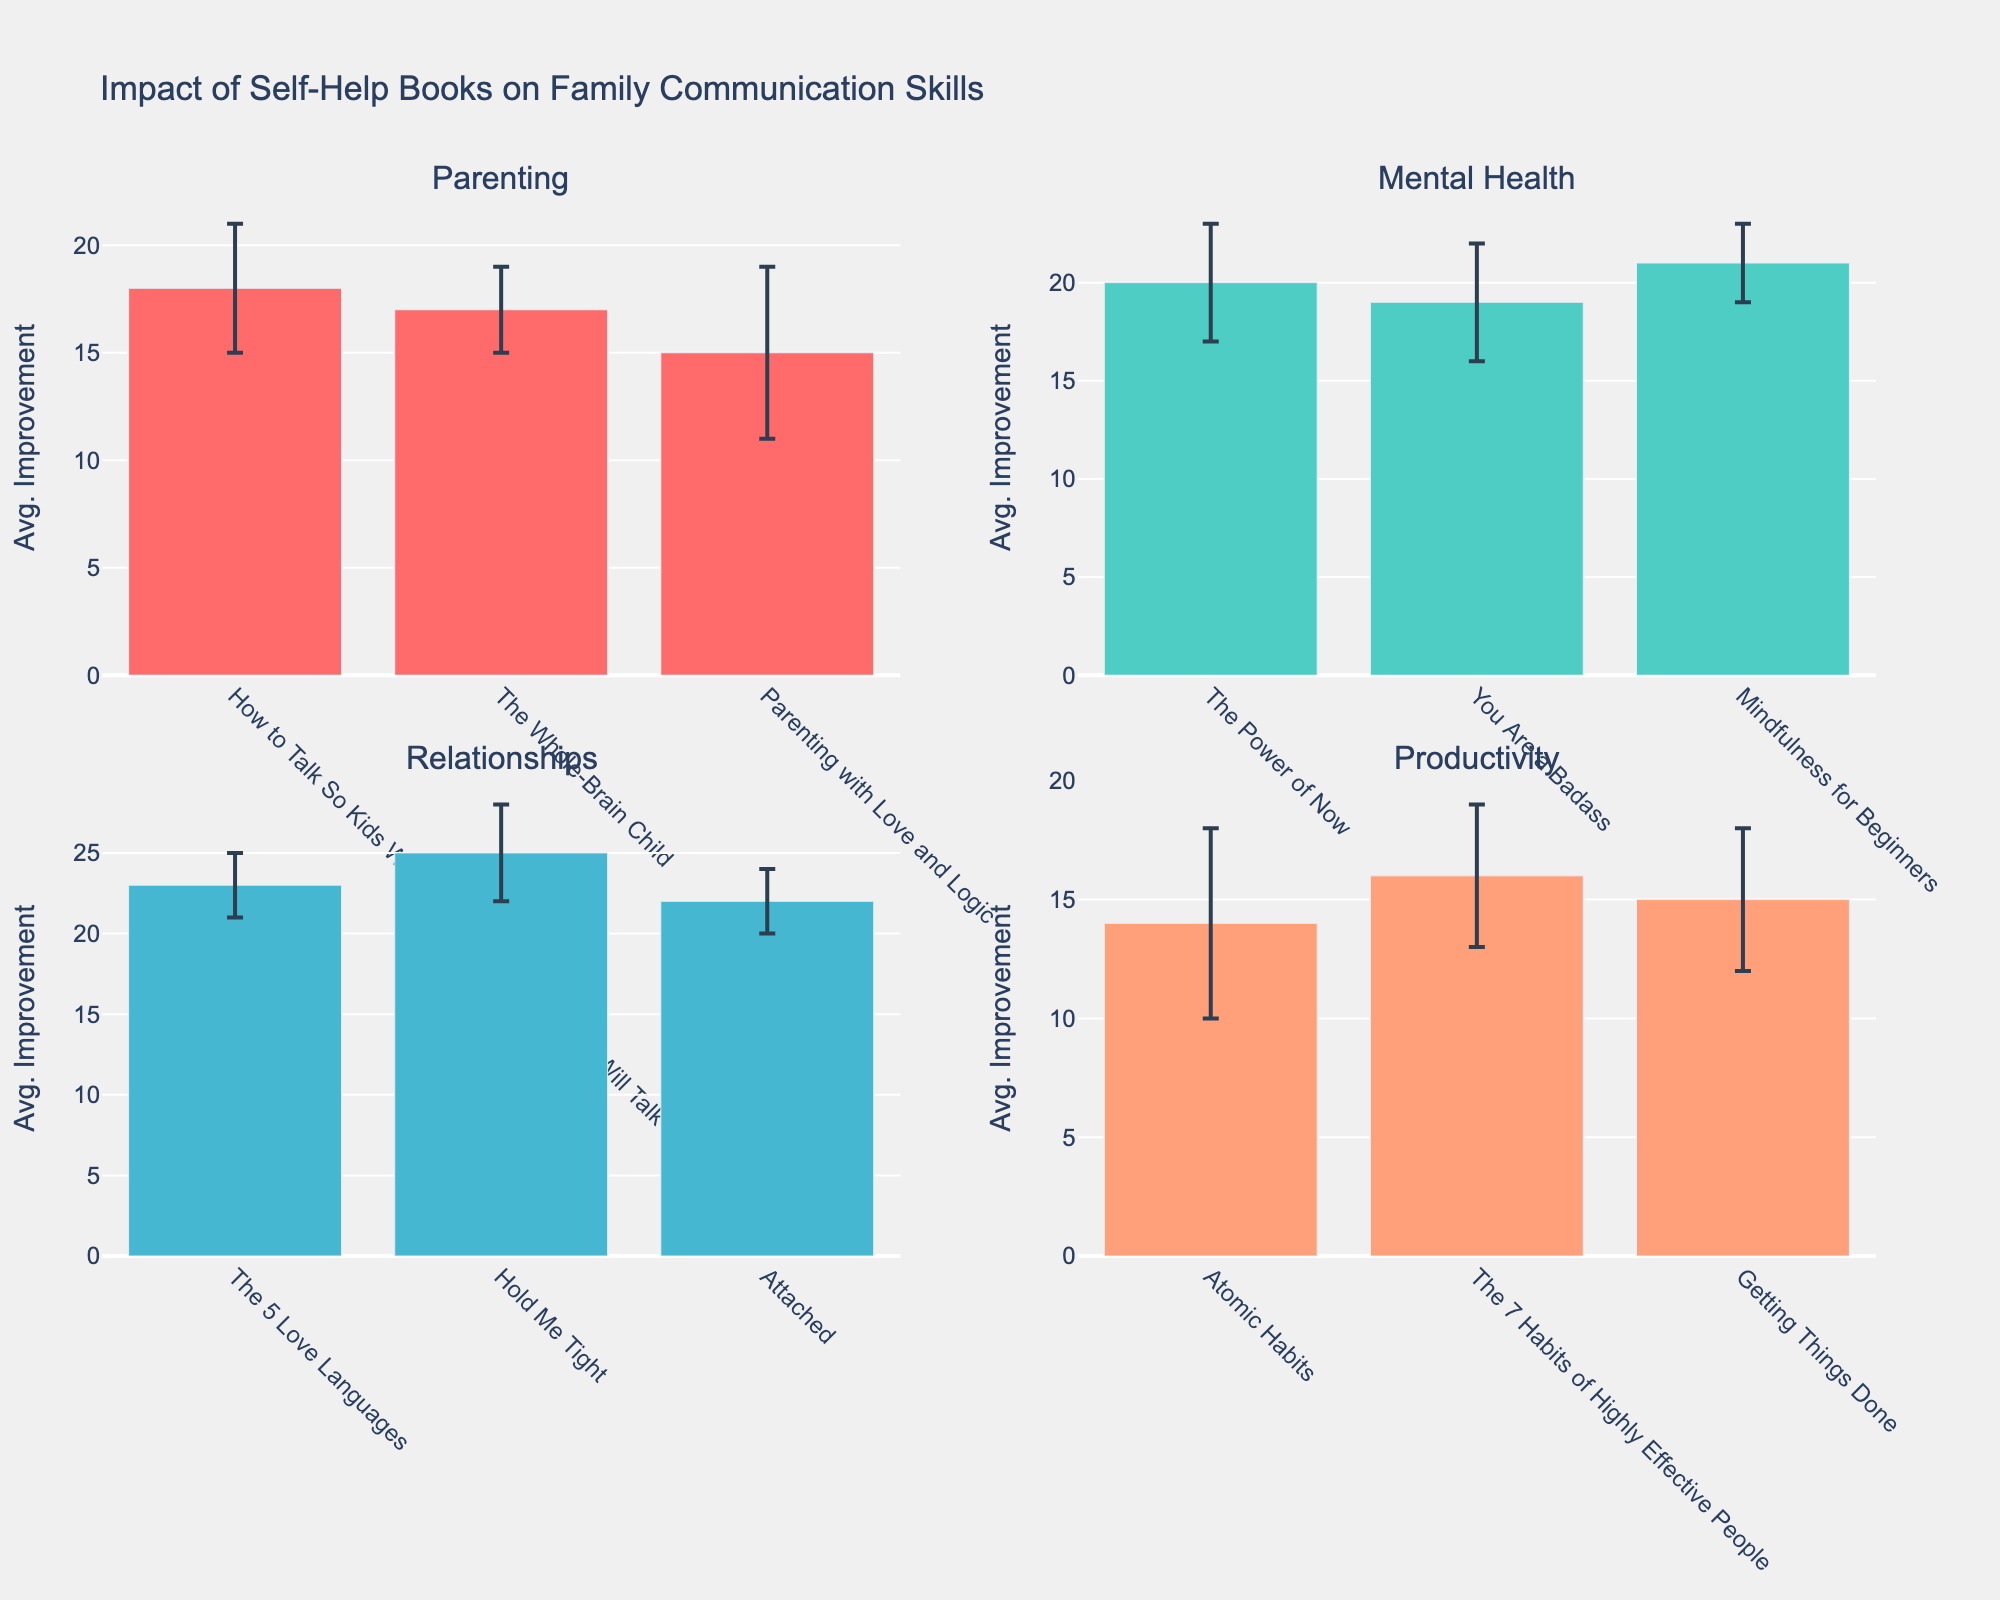Which book genre shows the highest average improvement in family communication skills? The subplot for the "Relationships" genre shows the highest bars overall, indicating the highest average improvements in family communication skills among the books listed.
Answer: Relationships Which book from the "Mental Health" genre has the highest average improvement in communication skills? In the "Mental Health" subplot, the book "Mindfulness for Beginners" shows the highest bar, indicating it has the highest average improvement in communication skills.
Answer: Mindfulness for Beginners What is the average improvement in communication skills for "How to Talk So Kids Will Listen & Listen So Kids Will Talk"? In the "Parenting" subplot, the book "How to Talk So Kids Will Listen & Listen So Kids Will Talk" has a bar reaching up to the average improvement of 18.
Answer: 18 Which subplot has the book with the largest standard error? The "Productivity" subplot shows the book "Atomic Habits" with the largest error bar, indicating it has the largest standard error.
Answer: Productivity How does the average improvement in communication skills for "The 5 Love Languages" compare to "Hold Me Tight"? In the "Relationships" subplot, "Hold Me Tight" has a higher bar (25) compared to "The 5 Love Languages" (23), indicating "Hold Me Tight" has a higher average improvement.
Answer: Hold Me Tight Calculate the total average improvement in communication skills from all "Parenting" books. Adding the average improvements for "How to Talk So Kids Will Listen & Listen So Kids Will Talk" (18), "The Whole-Brain Child" (17), and "Parenting with Love and Logic" (15) gives a total of 18 + 17 + 15 = 50.
Answer: 50 Which genre has the lowest average improvement in communication skills overall? Looking at the subplots, the "Productivity" genre has relatively lower bars compared to the other genres, indicating the lowest average improvement in communication skills.
Answer: Productivity What is the average value of the standard errors for the "Mental Health" books? The standard errors are 3, 3, and 2. Summing these gives 3 + 3 + 2 = 8, and dividing by the number of books (3) gives an average of 8/3 ≈ 2.67.
Answer: 2.67 Which book in the "Parenting" genre has the smallest standard error? In the "Parenting" subplot, "The Whole-Brain Child" shows the smallest error bar indicating it has the smallest standard error.
Answer: The Whole-Brain Child 